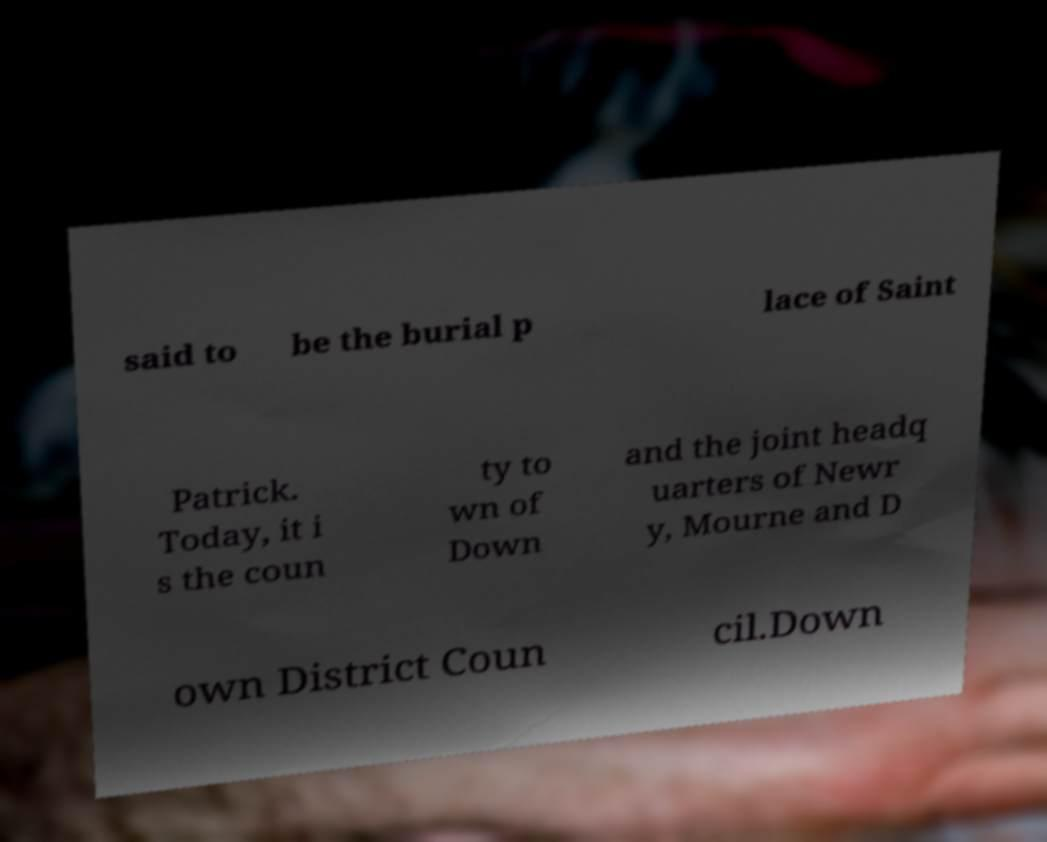I need the written content from this picture converted into text. Can you do that? said to be the burial p lace of Saint Patrick. Today, it i s the coun ty to wn of Down and the joint headq uarters of Newr y, Mourne and D own District Coun cil.Down 